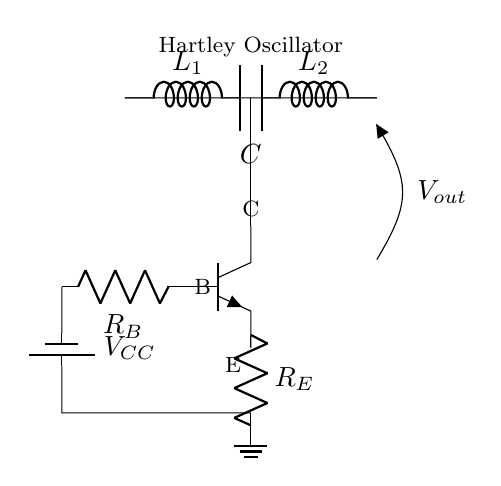What are the main components in the Hartley oscillator circuit? The circuit includes two inductors, one capacitor, a transistor, and resistors for biasing. These are essential for its operation, providing the necessary feedback and tuning capabilities.
Answer: Two inductors, one capacitor, a transistor, resistors What is the value of the power supply in this circuit? The battery labeled V_CC provides the power supply for the oscillator. The label indicates it is a battery, but the specific voltage value is not given directly in the visual; we typically assume standard values like 9V or 12V based on common use.
Answer: V_CC (voltage not specified) Which component is responsible for feedback in the Hartley oscillator? The feedback in the Hartley oscillator is primarily provided by the inductors L1 and L2, as they help determine the frequency of oscillation through their coupling and the resonant circuit formed with the capacitor.
Answer: Inductors L1 and L2 What is the purpose of the resistor labeled R_E? R_E is the emitter resistor of the transistor and it stabilizes the operating point by providing negative feedback. This helps improve the linearity and gain stability of the oscillator's output.
Answer: Stabilizes operating point How does the Hartley oscillator generate oscillations? The oscillations are generated through a combination of positive feedback and resonance in the tuned circuit (inductors and capacitor). When energy is fed back from the output to the input, it reinforces oscillation, making it sustain its frequency response.
Answer: Positive feedback and resonance What is the output voltage of this circuit described as? The output voltage is marked as V_out and typically measures the amplitude of the oscillations produced by the circuit. The exact value will depend on the circuit values and operating conditions, commonly analyzed with an oscilloscope.
Answer: V_out 